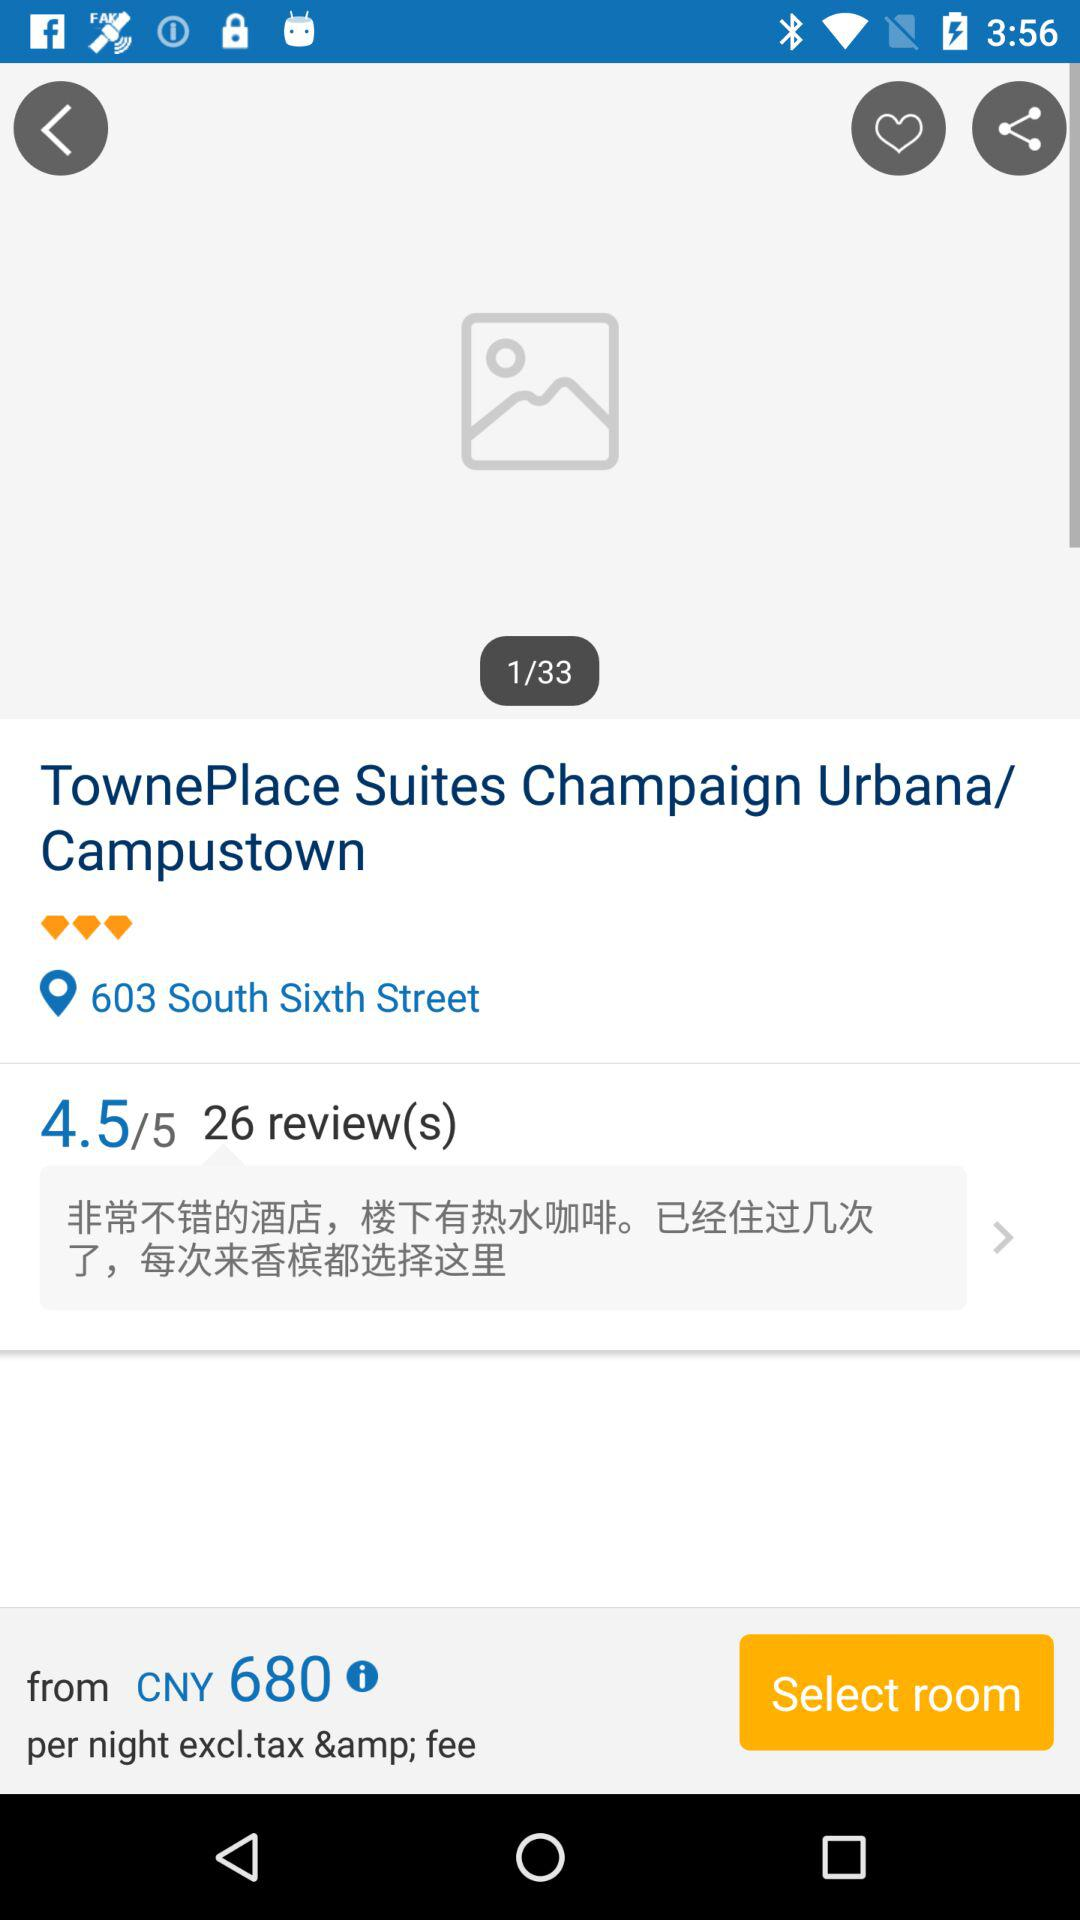How many reviews does the hotel have?
Answer the question using a single word or phrase. 26 